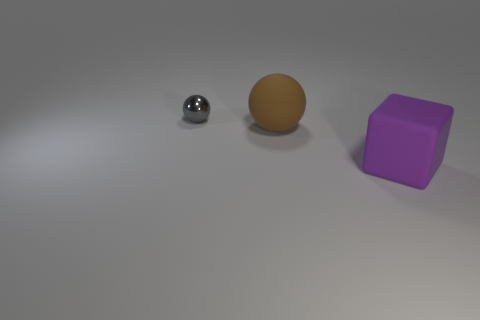There is a big rubber object behind the purple rubber block; is its shape the same as the matte thing that is to the right of the large brown rubber ball? No, the shapes are not the same. The large object behind the purple block is a cube, which has six square faces and edges of equal length. On the other hand, the matte object to the right of the brown ball is a sphere, which is perfectly round and has no edges. 